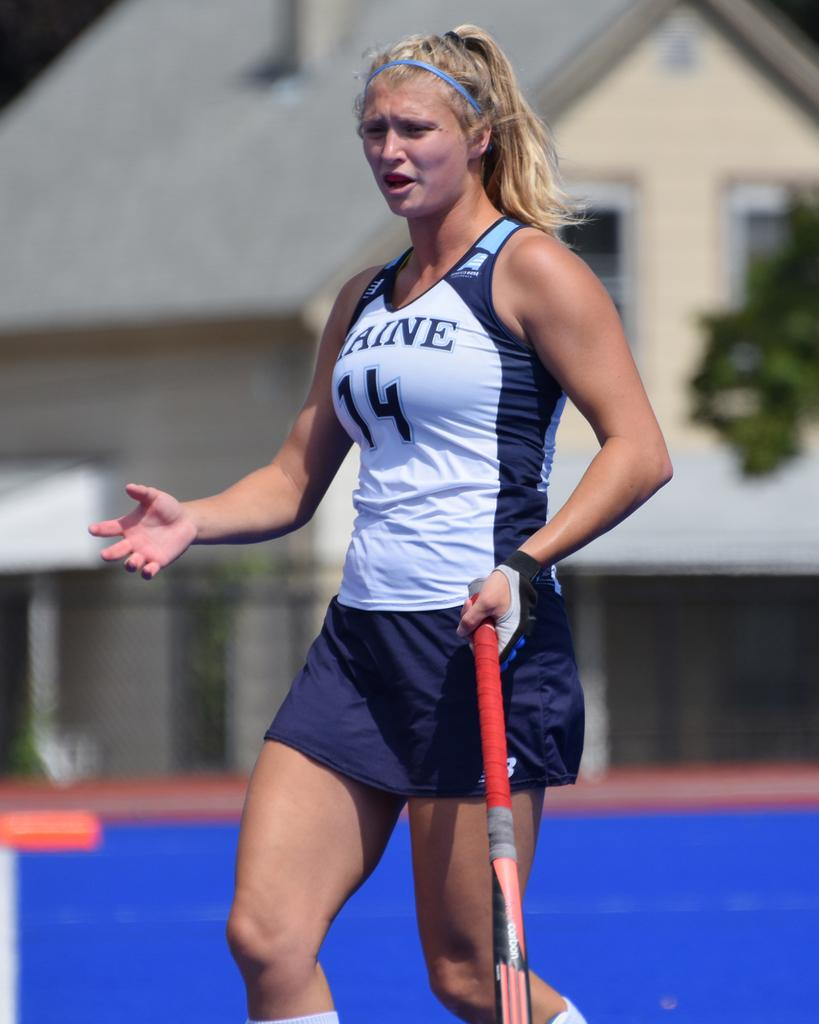Provide a one-sentence caption for the provided image. A woman athlete holding a field hockey stick with the number 14 on her uniform. 